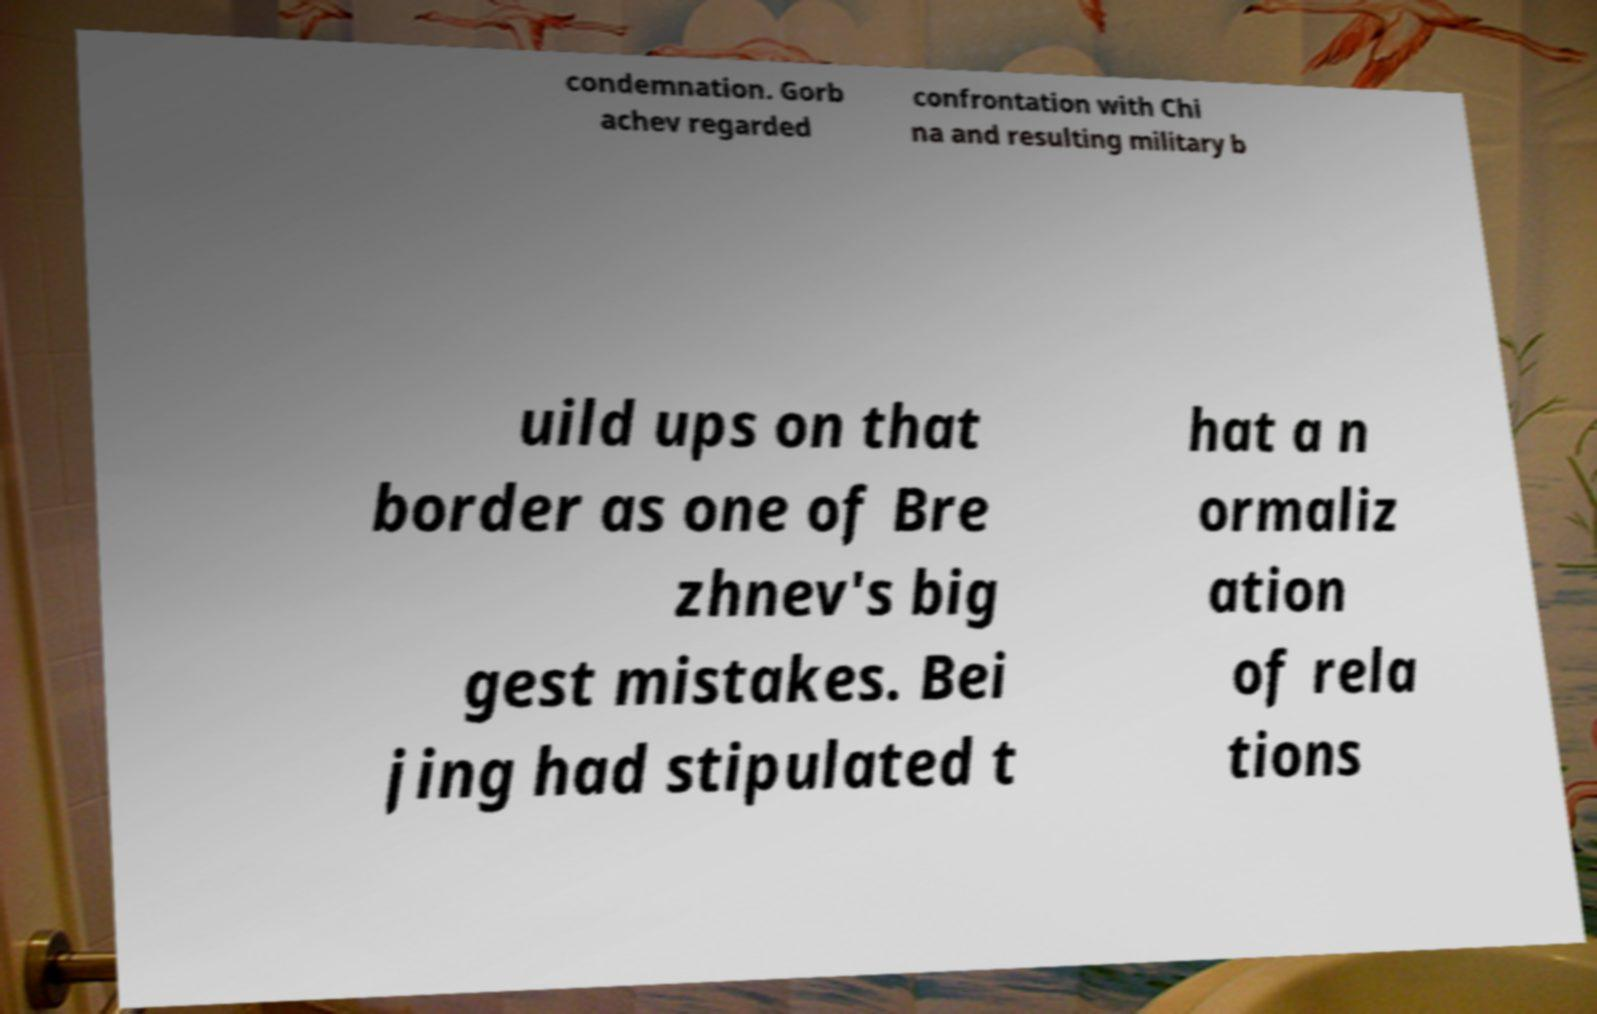For documentation purposes, I need the text within this image transcribed. Could you provide that? condemnation. Gorb achev regarded confrontation with Chi na and resulting military b uild ups on that border as one of Bre zhnev's big gest mistakes. Bei jing had stipulated t hat a n ormaliz ation of rela tions 